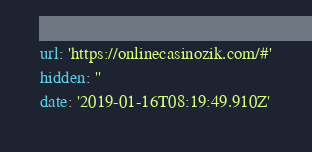<code> <loc_0><loc_0><loc_500><loc_500><_YAML_>url: 'https://onlinecasinozik.com/#'
hidden: ''
date: '2019-01-16T08:19:49.910Z'
</code> 